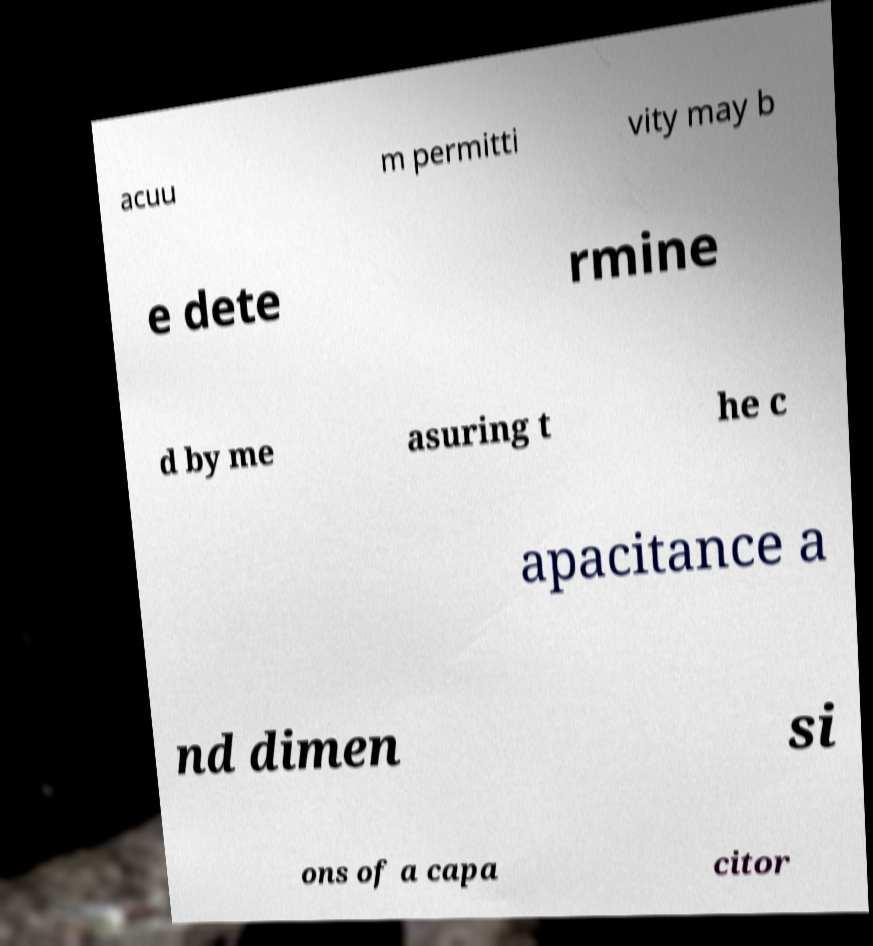Please read and relay the text visible in this image. What does it say? acuu m permitti vity may b e dete rmine d by me asuring t he c apacitance a nd dimen si ons of a capa citor 